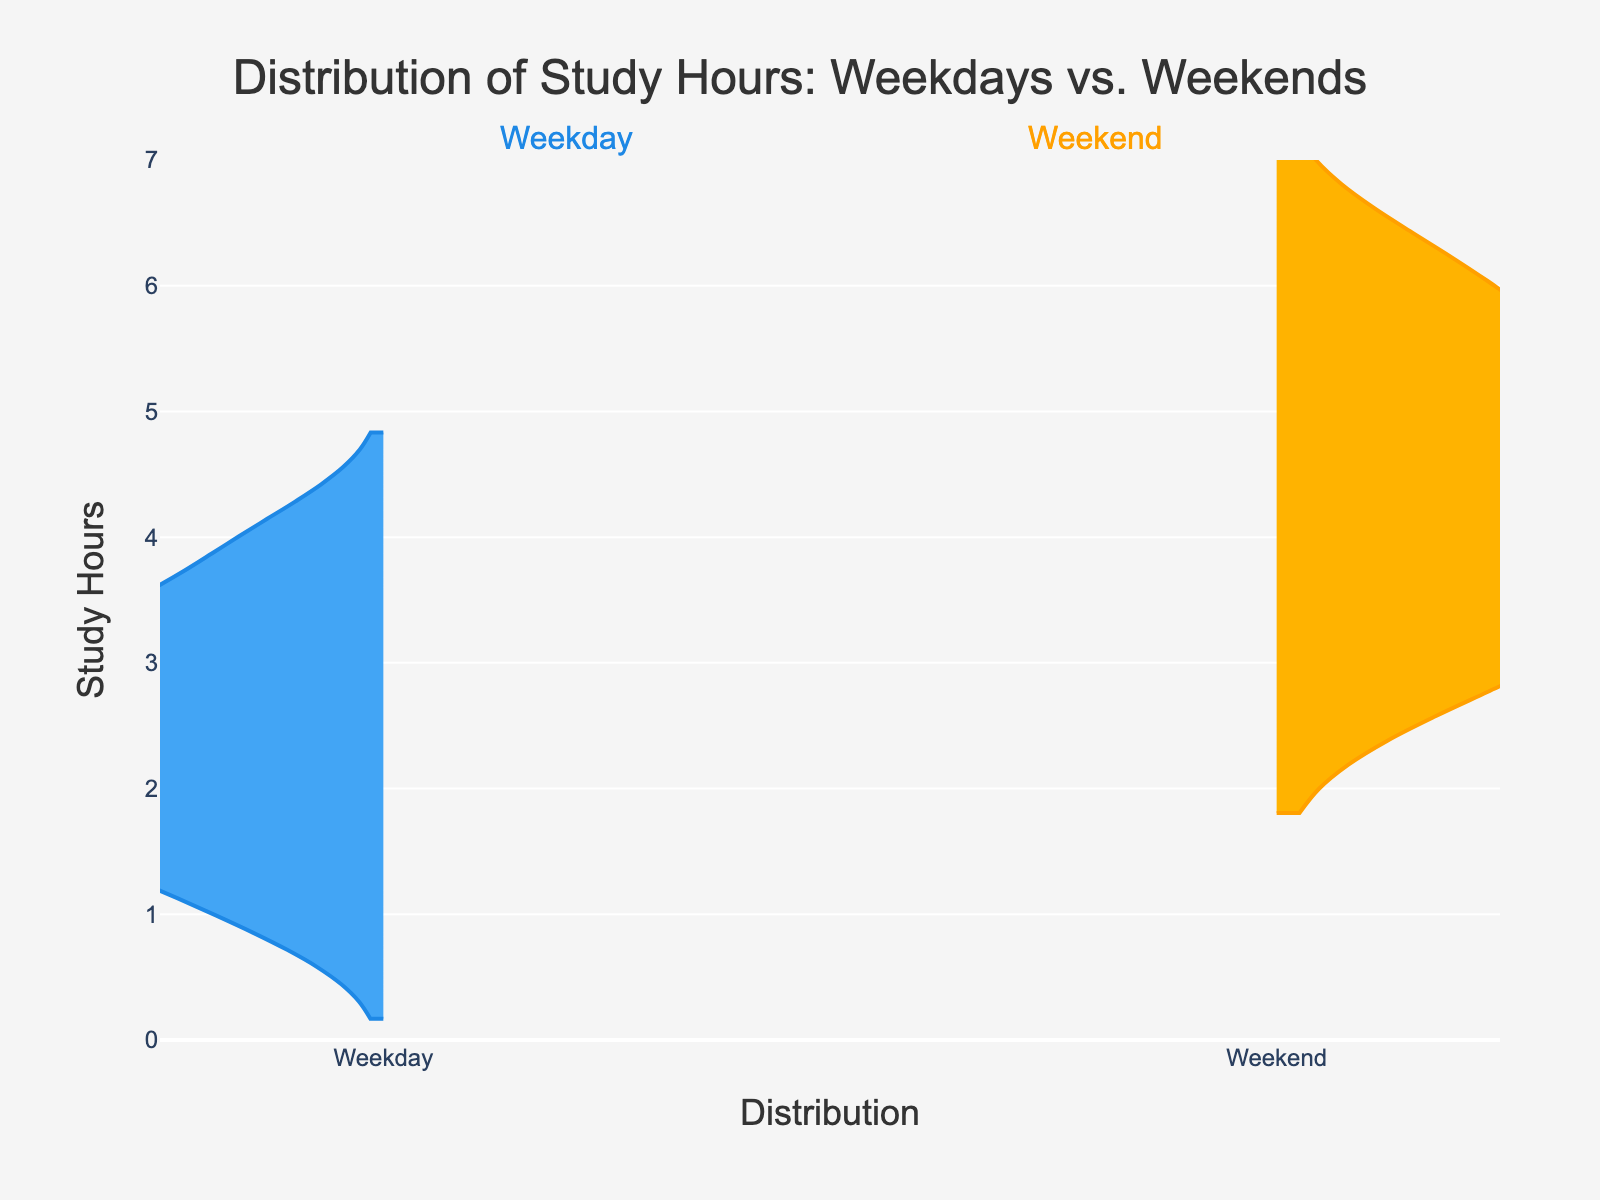what is the title of the figure? The title of the figure is displayed at the top, which helps in understanding the context of the data presented. It reads "Distribution of Study Hours: Weekdays vs. Weekends".
Answer: Distribution of Study Hours: Weekdays vs. Weekends What is the maximum study hours on weekends? The maximum study hours on weekends can be observed by looking at the topmost part of the weekend violin plot. It reaches up to 6 hours.
Answer: 6 hours Do students study more on weekdays or weekends on average? Visually, the weekend violin plot extends higher, indicating a higher average. This suggests that on average, students tend to study more on weekends than weekdays.
Answer: Weekends How do the distributions of study hours compare between weekdays and weekends? The distributions can be compared by looking at the spread and shape of each violin plot. The weekend plot is more spread out and peaks higher, indicating more variability and higher study hours compared to the weekday plot.
Answer: Weekends have higher study hours and more variability What is the median study hours on weekdays? The median can be visually estimated where the density of the violin plot is thickest. For weekdays, it appears thickest around 2 to 3 hours, indicating the median.
Answer: 2 to 3 hours Are there more students studying less than 2 hours on weekdays than weekends? By comparing the density at the lower part of each violin plot, we can see that there is a noticeable density below 2 hours for weekdays, while weekends have almost no density below 2 hours.
Answer: Yes What is the range of study hours on weekdays? The range can be identified by noting the lowest and highest points on the weekday violin plot. It starts at around 1 hour and goes up to 4 hours.
Answer: 1 to 4 hours Is there a more consistent study pattern on weekdays or weekends? Consistency can be inferred from the tightness of the violin plot. The weekday plot is narrower, indicating a more consistent study pattern compared to the wider weekend plot.
Answer: Weekdays Which day, weekday or weekend, shows a higher peak in study hours distribution? The peak can be discerned where the violin plot bulges the most. The weekend plot shows a higher bulge around the 5-6 hour mark compared to weekdays.
Answer: Weekends What does the gap in the range represent in the plot? The gap between the lowest and highest points of the plots depicts the range of study hours. A larger spread indicates more variability in the range of study hours among students.
Answer: Variability in study hours 